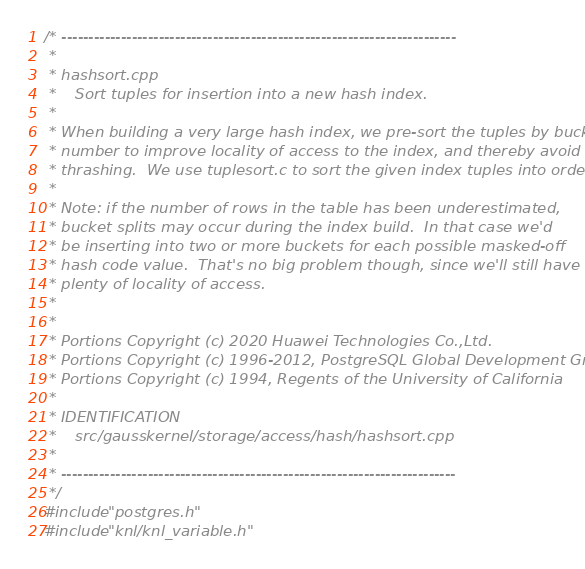<code> <loc_0><loc_0><loc_500><loc_500><_C++_>/* -------------------------------------------------------------------------
 *
 * hashsort.cpp
 *    Sort tuples for insertion into a new hash index.
 *
 * When building a very large hash index, we pre-sort the tuples by bucket
 * number to improve locality of access to the index, and thereby avoid
 * thrashing.  We use tuplesort.c to sort the given index tuples into order.
 *
 * Note: if the number of rows in the table has been underestimated,
 * bucket splits may occur during the index build.	In that case we'd
 * be inserting into two or more buckets for each possible masked-off
 * hash code value.  That's no big problem though, since we'll still have
 * plenty of locality of access.
 *
 *
 * Portions Copyright (c) 2020 Huawei Technologies Co.,Ltd.
 * Portions Copyright (c) 1996-2012, PostgreSQL Global Development Group
 * Portions Copyright (c) 1994, Regents of the University of California
 *
 * IDENTIFICATION
 *	  src/gausskernel/storage/access/hash/hashsort.cpp
 *
 * -------------------------------------------------------------------------
 */
#include "postgres.h"
#include "knl/knl_variable.h"
</code> 